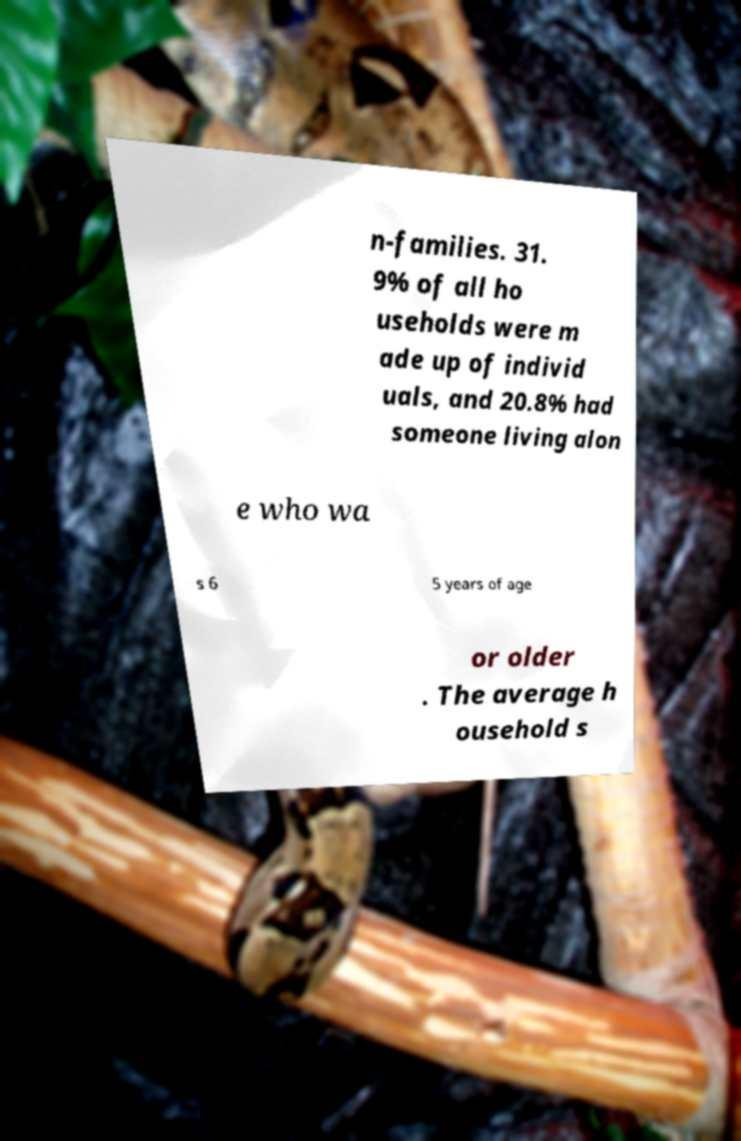I need the written content from this picture converted into text. Can you do that? n-families. 31. 9% of all ho useholds were m ade up of individ uals, and 20.8% had someone living alon e who wa s 6 5 years of age or older . The average h ousehold s 